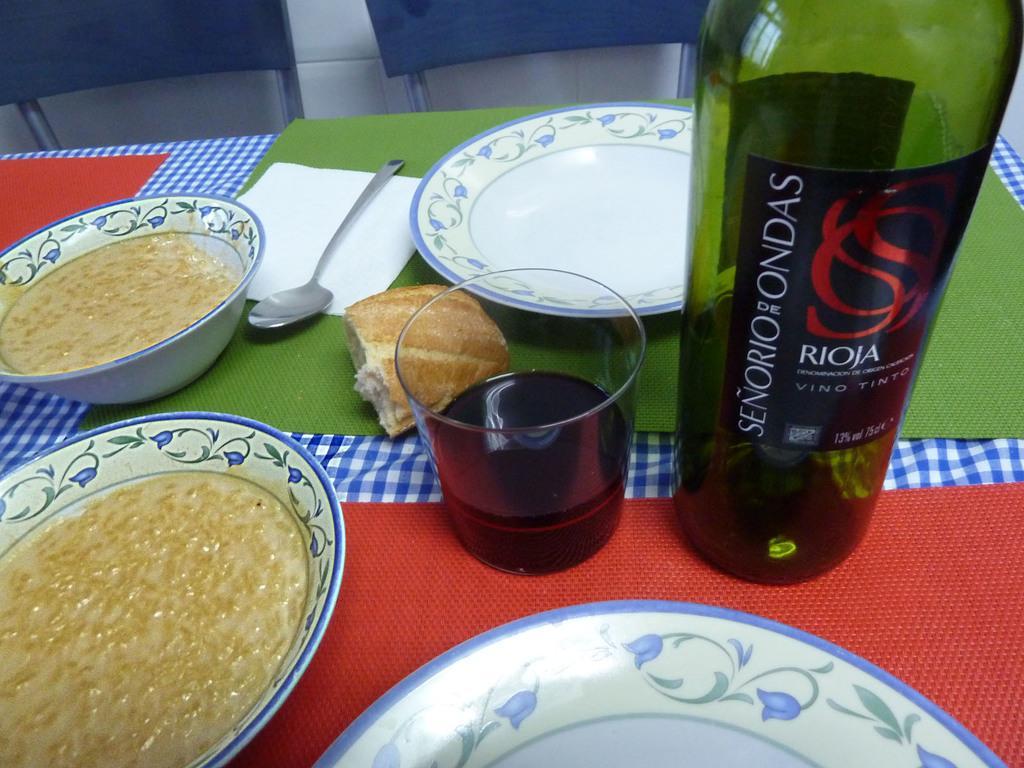How would you summarize this image in a sentence or two? in this image i can see plates, food in them, a bowl,spoon, a water bottle, a glass on the table and two chairs. 